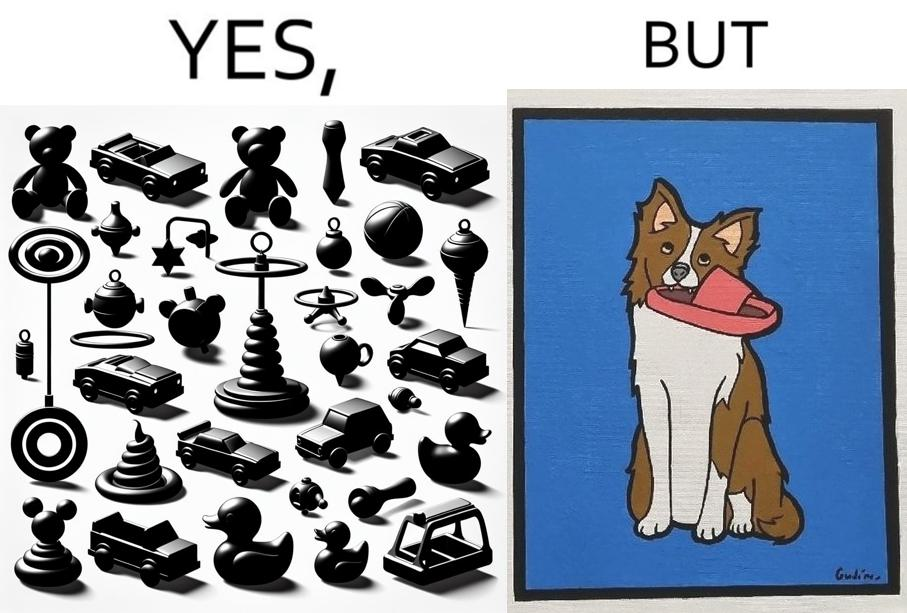Compare the left and right sides of this image. In the left part of the image: a bunch of toys In the right part of the image: a dog holding a slipper 